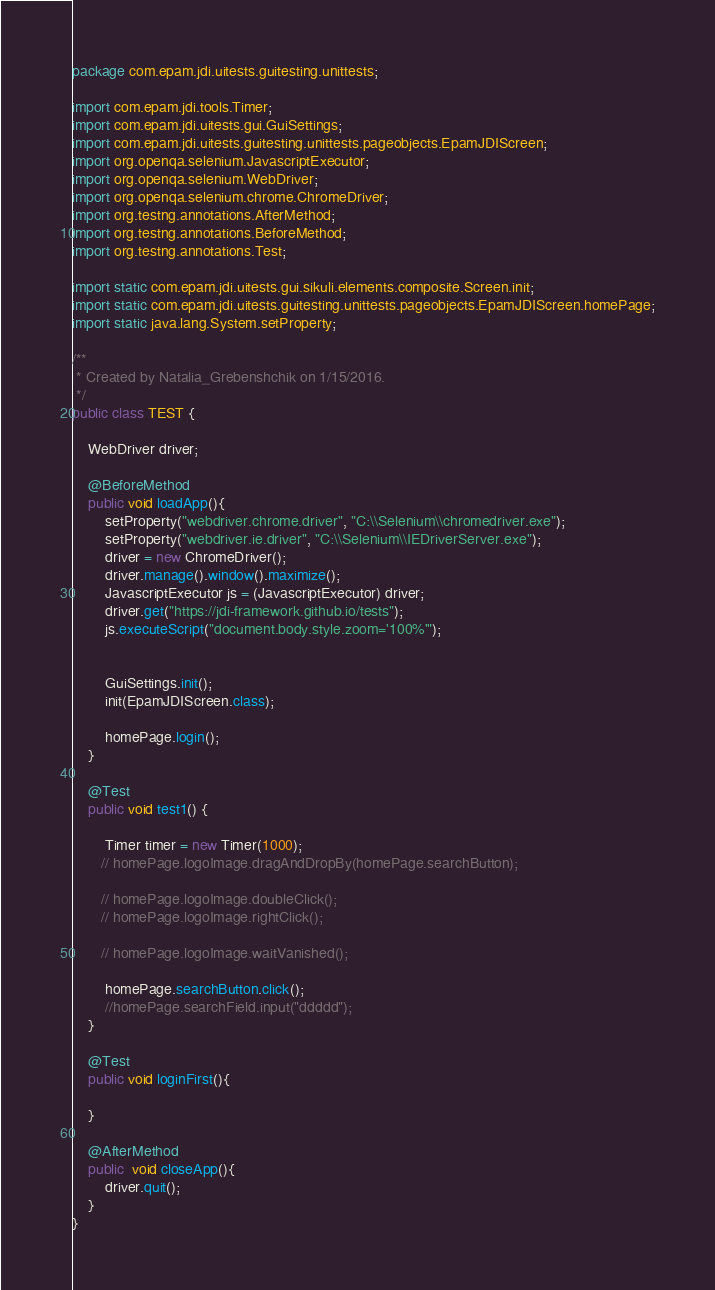Convert code to text. <code><loc_0><loc_0><loc_500><loc_500><_Java_>package com.epam.jdi.uitests.guitesting.unittests;

import com.epam.jdi.tools.Timer;
import com.epam.jdi.uitests.gui.GuiSettings;
import com.epam.jdi.uitests.guitesting.unittests.pageobjects.EpamJDIScreen;
import org.openqa.selenium.JavascriptExecutor;
import org.openqa.selenium.WebDriver;
import org.openqa.selenium.chrome.ChromeDriver;
import org.testng.annotations.AfterMethod;
import org.testng.annotations.BeforeMethod;
import org.testng.annotations.Test;

import static com.epam.jdi.uitests.gui.sikuli.elements.composite.Screen.init;
import static com.epam.jdi.uitests.guitesting.unittests.pageobjects.EpamJDIScreen.homePage;
import static java.lang.System.setProperty;

/**
 * Created by Natalia_Grebenshchik on 1/15/2016.
 */
public class TEST {

    WebDriver driver;

    @BeforeMethod
    public void loadApp(){
        setProperty("webdriver.chrome.driver", "C:\\Selenium\\chromedriver.exe");
        setProperty("webdriver.ie.driver", "C:\\Selenium\\IEDriverServer.exe");
        driver = new ChromeDriver();
        driver.manage().window().maximize();
        JavascriptExecutor js = (JavascriptExecutor) driver;
        driver.get("https://jdi-framework.github.io/tests");
        js.executeScript("document.body.style.zoom='100%'");


        GuiSettings.init();
        init(EpamJDIScreen.class);

        homePage.login();
    }

    @Test
    public void test1() {

        Timer timer = new Timer(1000);
       // homePage.logoImage.dragAndDropBy(homePage.searchButton);

       // homePage.logoImage.doubleClick();
       // homePage.logoImage.rightClick();

       // homePage.logoImage.waitVanished();

        homePage.searchButton.click();
        //homePage.searchField.input("ddddd");
    }

    @Test
    public void loginFirst(){

    }

    @AfterMethod
    public  void closeApp(){
        driver.quit();
    }
}
</code> 